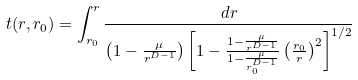Convert formula to latex. <formula><loc_0><loc_0><loc_500><loc_500>t ( r , r _ { 0 } ) = \int _ { r _ { 0 } } ^ { r } \frac { d r } { \left ( 1 - \frac { \mu } { r ^ { D - 1 } } \right ) \left [ 1 - \frac { 1 - \frac { \mu } { r ^ { D - 1 } } } { 1 - \frac { \mu } { r _ { 0 } ^ { D - 1 } } } \left ( \frac { r _ { 0 } } { r } \right ) ^ { 2 } \right ] ^ { 1 / 2 } }</formula> 